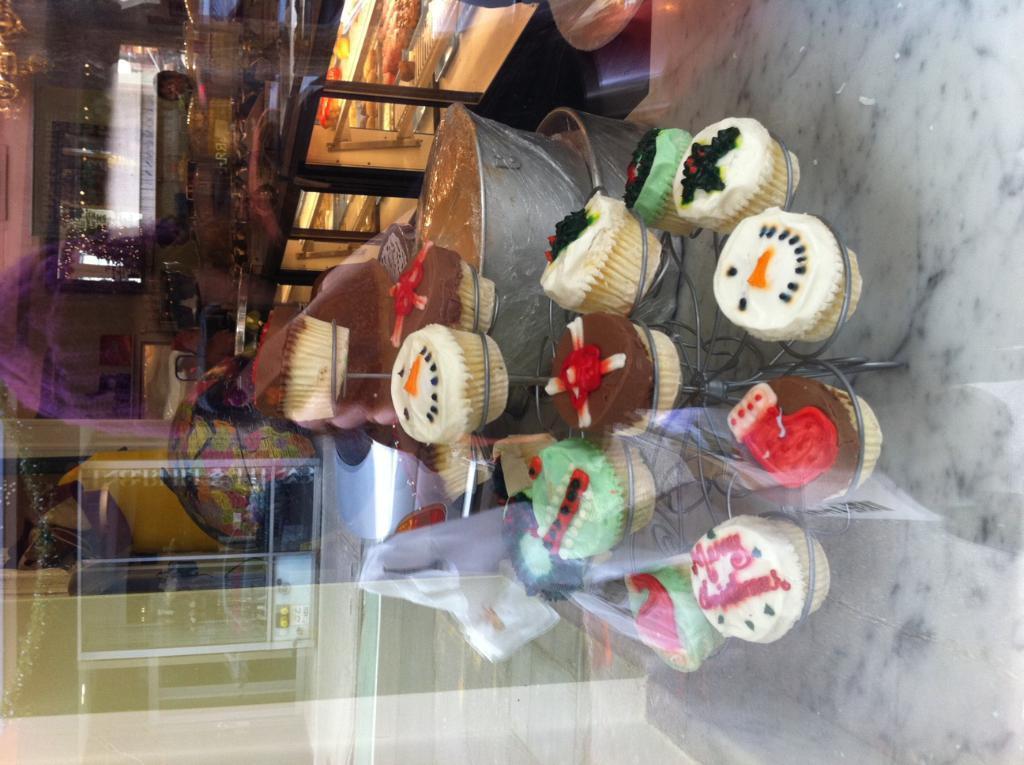Please provide a concise description of this image. There are different cupcakes on a stand. In the back there is a big vessel with some item. In the background there is a cupboard with a platform and a glass wall. In that there are racks with some items. And it is looking blurred in the background. 